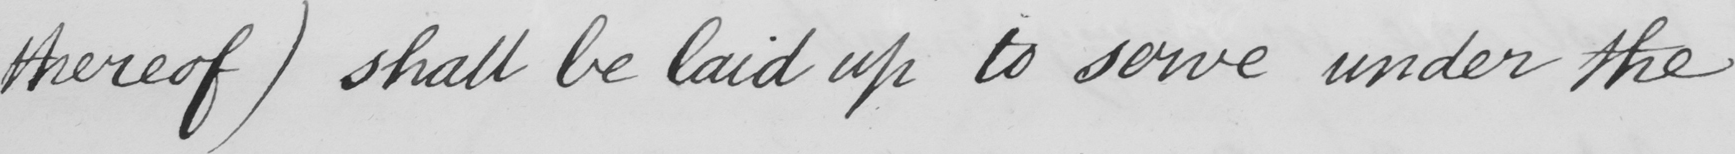Can you read and transcribe this handwriting? thereof )  shall be laid up to serve under the 